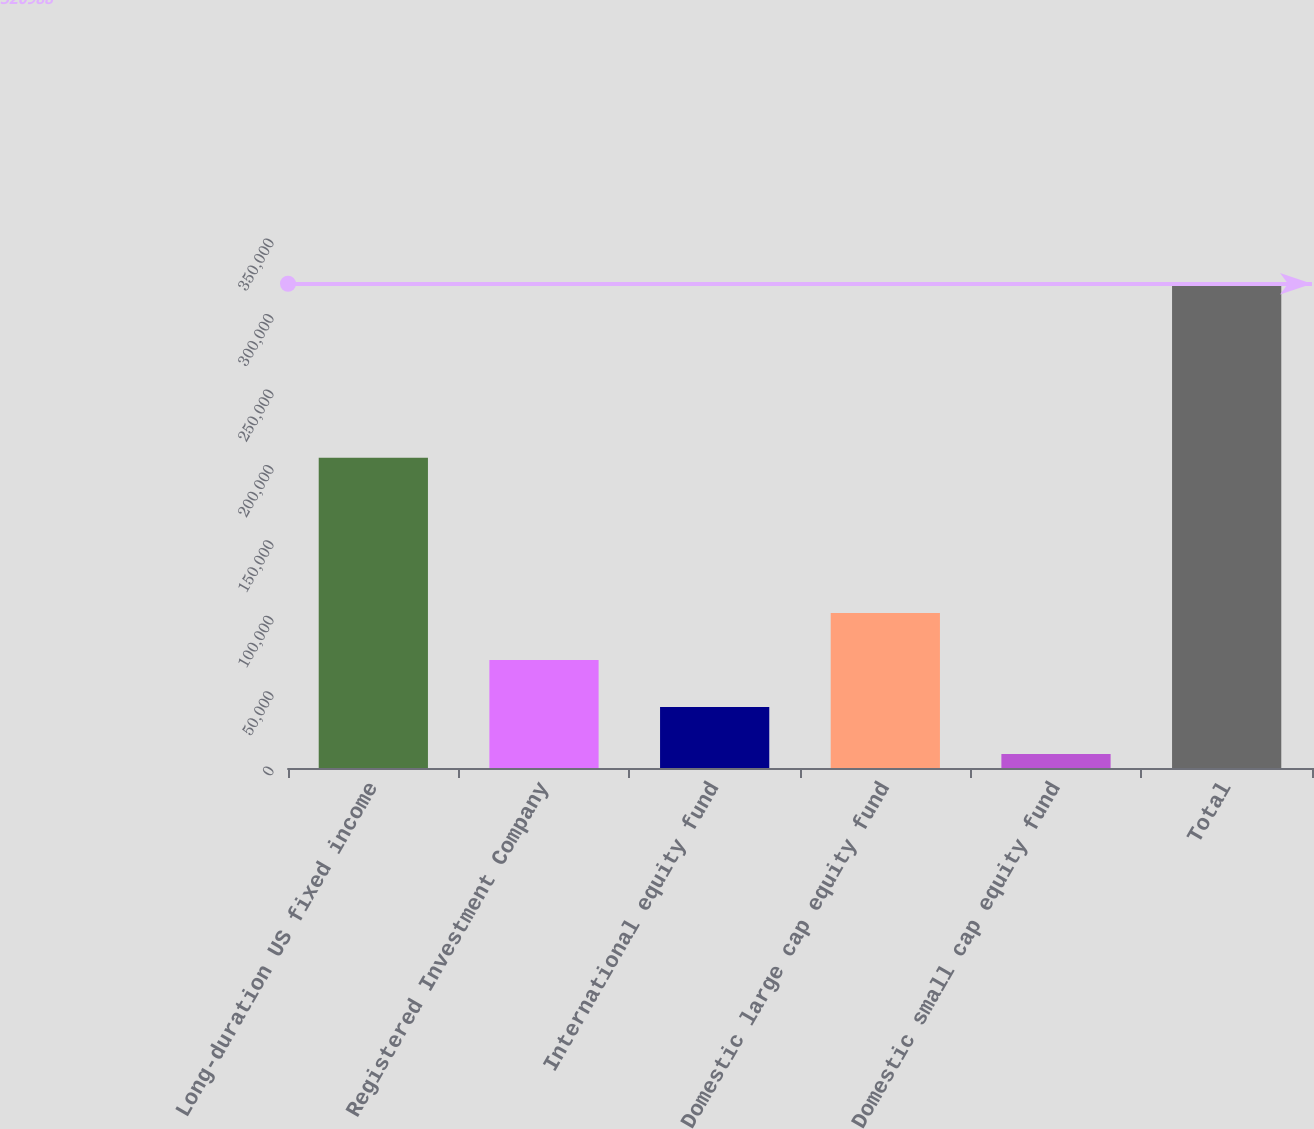Convert chart. <chart><loc_0><loc_0><loc_500><loc_500><bar_chart><fcel>Long-duration US fixed income<fcel>Registered Investment Company<fcel>International equity fund<fcel>Domestic large cap equity fund<fcel>Domestic small cap equity fund<fcel>Total<nl><fcel>205695<fcel>71563.2<fcel>40385.1<fcel>102741<fcel>9207<fcel>320988<nl></chart> 